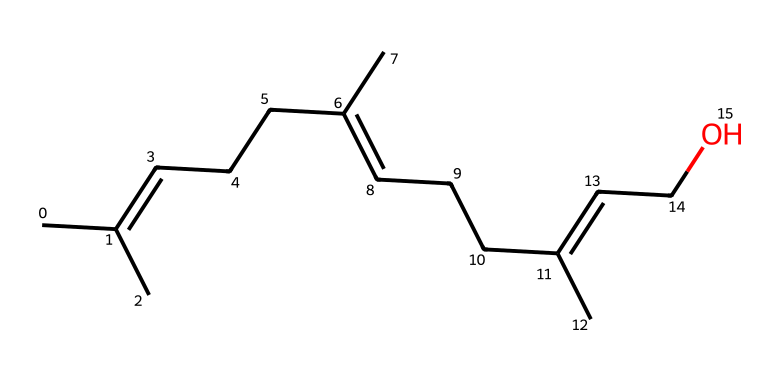What is the molecular formula of this compound? By counting the number of carbon (C) and oxygen (O) atoms in the SMILES representation, we find that there are 12 carbon atoms and 1 oxygen atom, leading to the molecular formula C12H22O.
Answer: C12H22O How many double bonds are present in the structure? Analyzing the carbon chains in the SMILES, we identify double bonds between certain carbon atoms. In this structure, there are three double bonds indicated by the '=' signs.
Answer: 3 What type of functional group is present in this molecule? The presence of the hydroxyl group (−OH) represented in the SMILES indicates that this compound has an alcohol functional group, which is characterized by the presence of oxygen bonded to a hydrogen atom.
Answer: alcohol What does the presence of oxygen imply about the molecule's properties? Oxygen often increases polarity in organic compounds, affecting solubility. In this case, the alcohol group suggests that this compound may have moderate polarity, contributing to its solubility in water.
Answer: moderate polarity Is this compound likely to be flammable? Given that the structure contains multiple carbon chains and a functional group (alcohol), compounds with such characteristics are generally flammable, especially when they consist of hydrocarbons.
Answer: yes What can we infer about the volatility of this chemical? The presence of a long carbon chain suggests that this compound is likely to have a higher boiling point, but the alcohol group can make it more volatile than similar hydrocarbons without functional groups, implying moderate volatility.
Answer: moderate volatility 